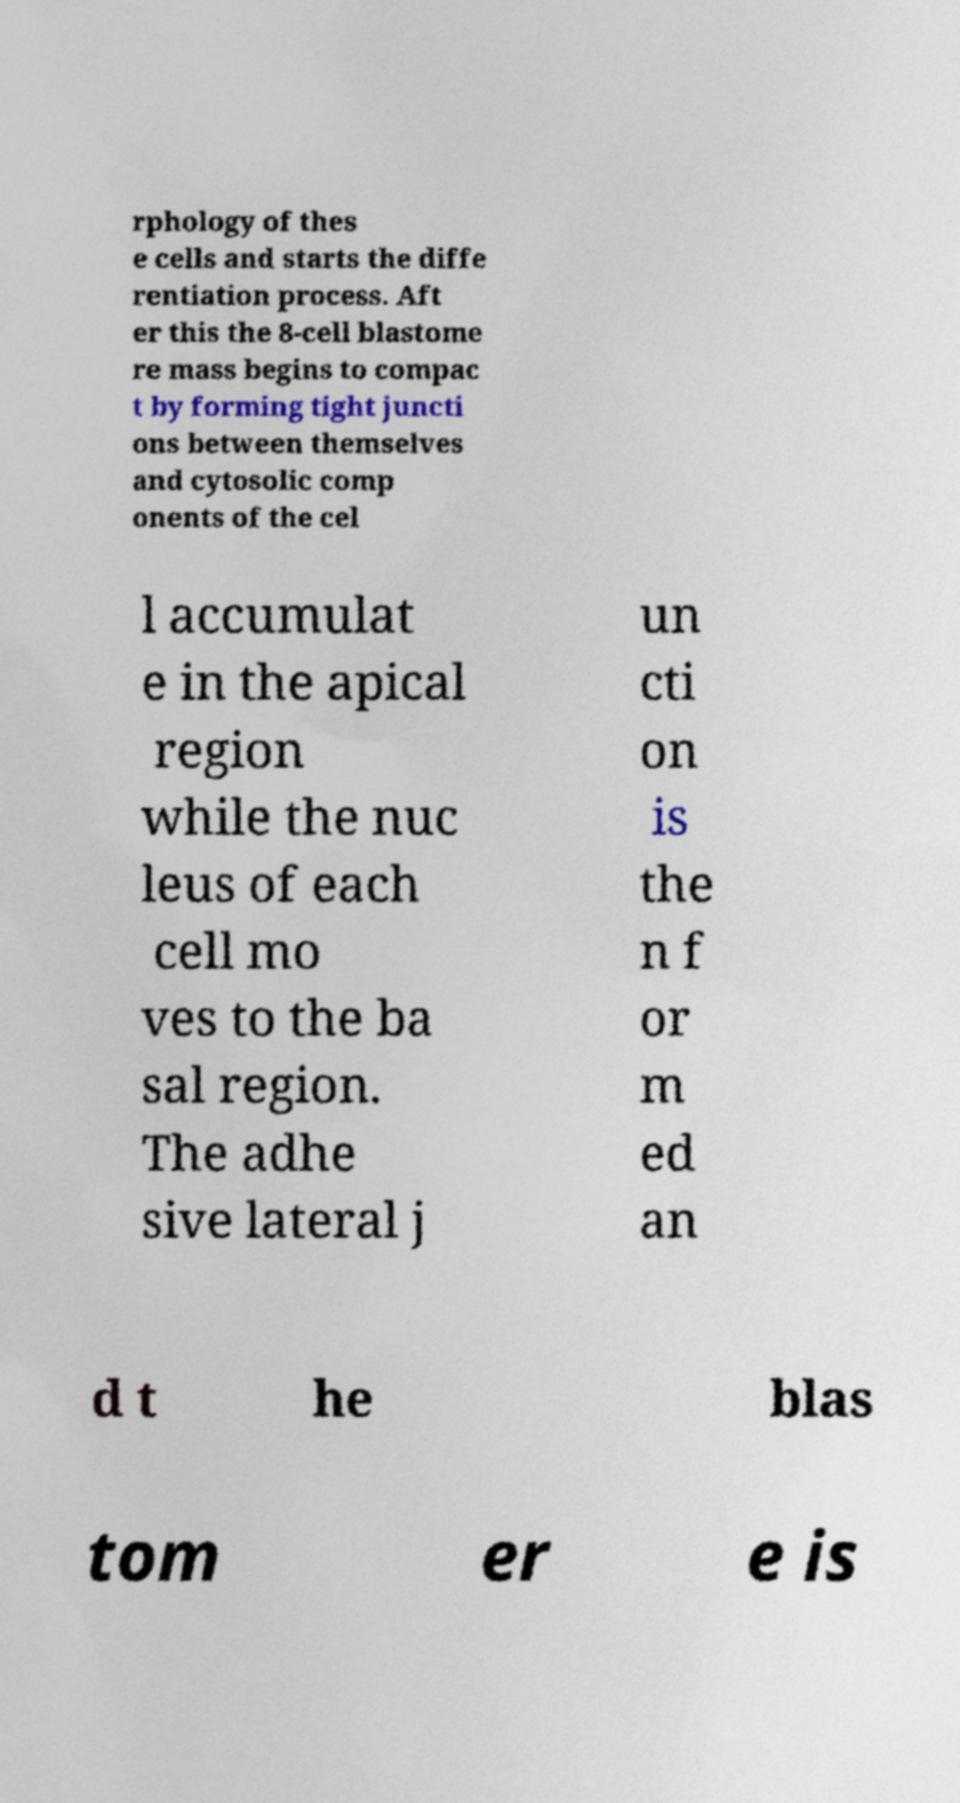For documentation purposes, I need the text within this image transcribed. Could you provide that? rphology of thes e cells and starts the diffe rentiation process. Aft er this the 8-cell blastome re mass begins to compac t by forming tight juncti ons between themselves and cytosolic comp onents of the cel l accumulat e in the apical region while the nuc leus of each cell mo ves to the ba sal region. The adhe sive lateral j un cti on is the n f or m ed an d t he blas tom er e is 